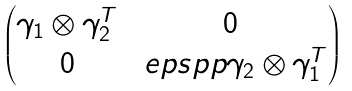<formula> <loc_0><loc_0><loc_500><loc_500>\begin{pmatrix} \gamma _ { 1 } \otimes \gamma _ { 2 } ^ { T } & 0 \\ 0 & \ e p s p p \gamma _ { 2 } \otimes \gamma _ { 1 } ^ { T } \end{pmatrix}</formula> 